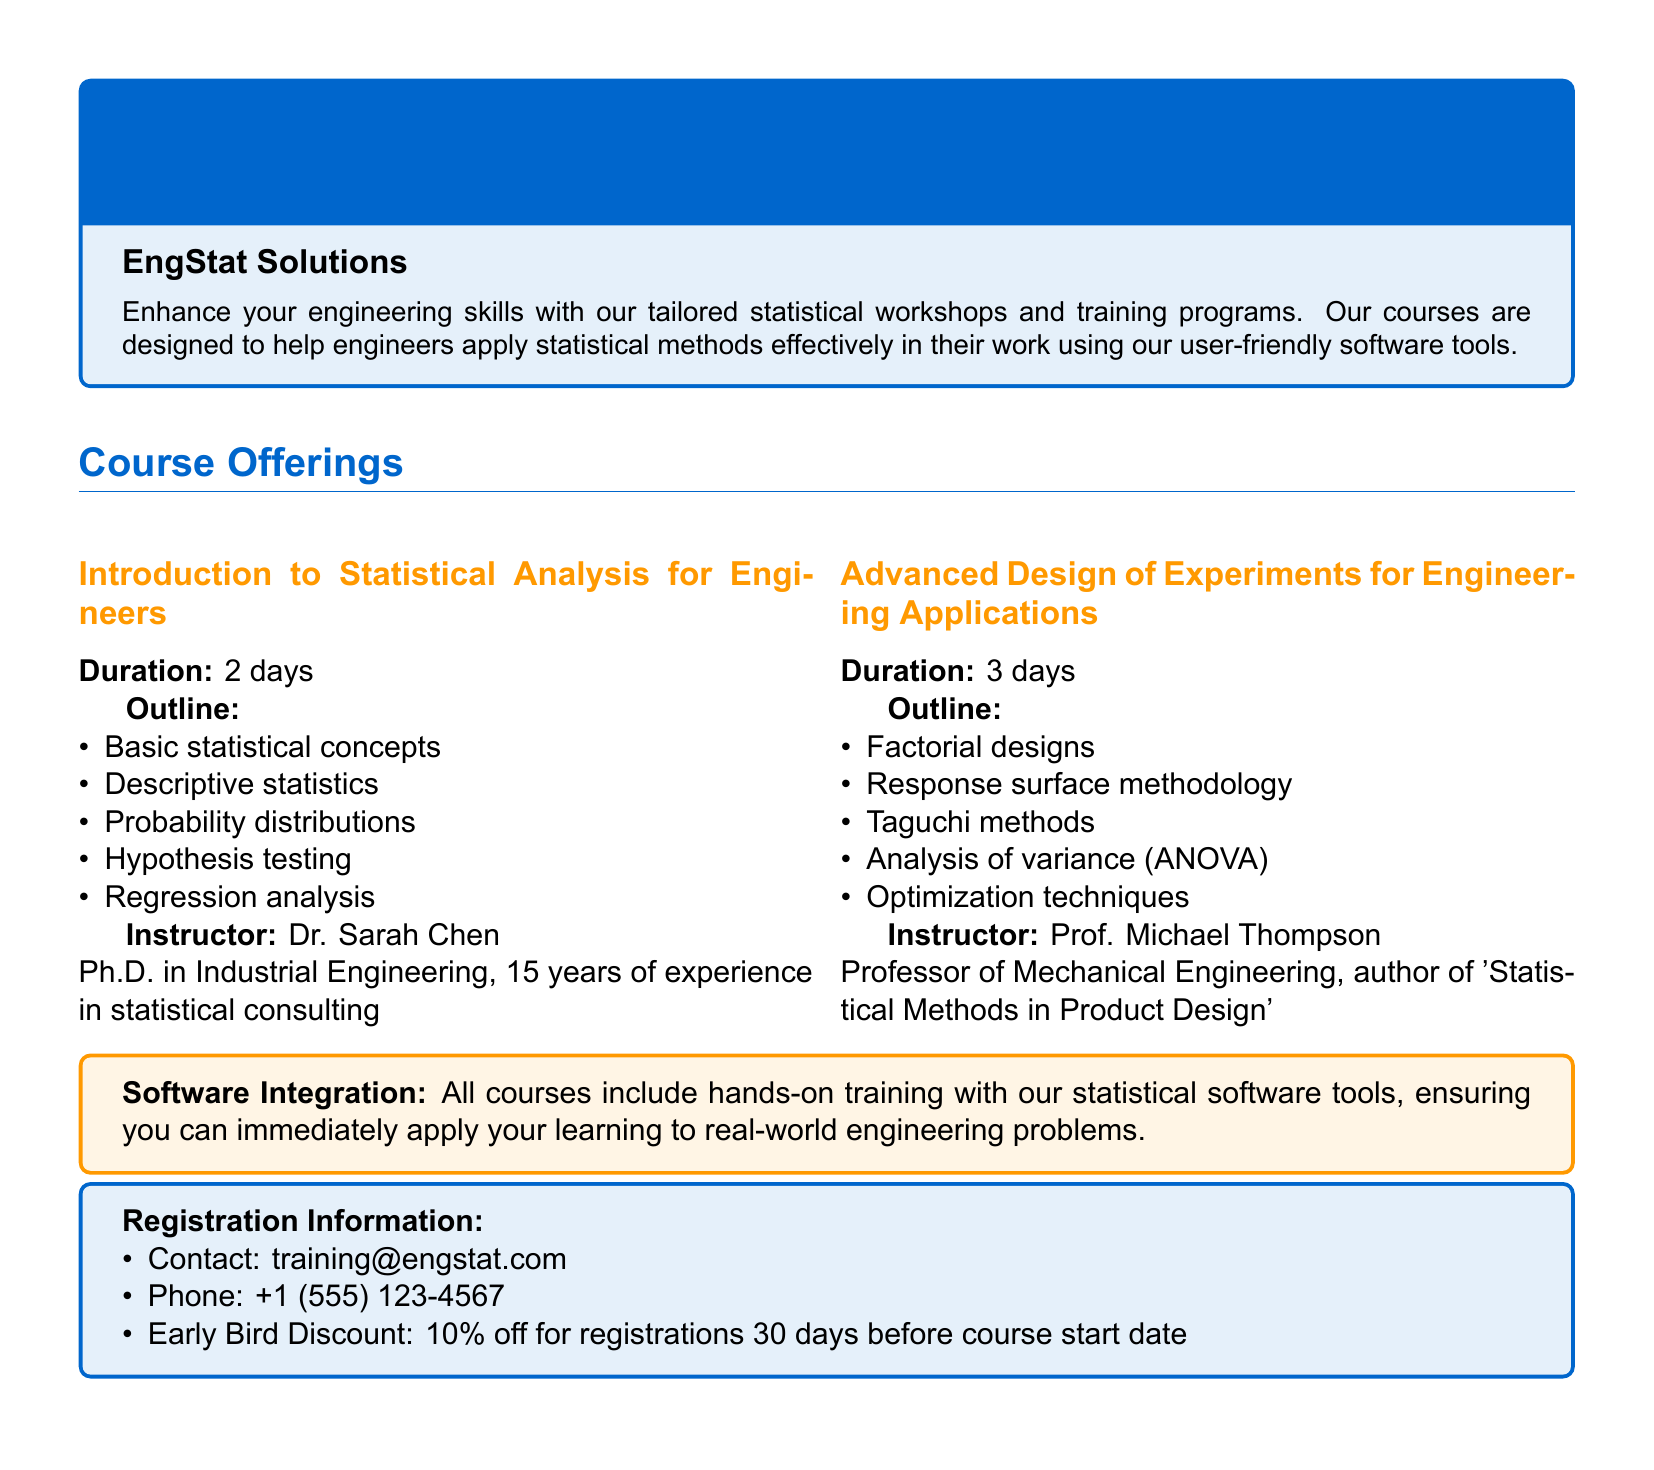What is the duration of the "Introduction to Statistical Analysis for Engineers" course? The duration is specified in the course offerings section, which states it is 2 days.
Answer: 2 days Who is the instructor for the "Advanced Design of Experiments for Engineering Applications"? The instructor is mentioned in the course details and is Prof. Michael Thompson.
Answer: Prof. Michael Thompson What statistical concept is covered in the first course? The first course outline lists basic statistical concepts among other topics.
Answer: Basic statistical concepts What is the total duration of the "Advanced Design of Experiments for Engineering Applications" course? The total duration is provided in the course offerings section, which notes it lasts for 3 days.
Answer: 3 days What discount is available for early registrations? The document states that there is a 10% discount for early bird registrations.
Answer: 10% What is the contact email for registration information? This information is clearly listed in the registration section, where it mentions training@engstat.com as the contact email.
Answer: training@engstat.com What type of training is included in all courses? The catalog states that all courses include hands-on training with statistical software tools.
Answer: Hands-on training How many years of experience does Dr. Sarah Chen have? The document specifies that Dr. Sarah Chen has 15 years of experience in statistical consulting.
Answer: 15 years What method is mentioned in the outline for advanced experiments? The course outline includes several methods, among which Taguchi methods are specifically cited.
Answer: Taguchi methods 